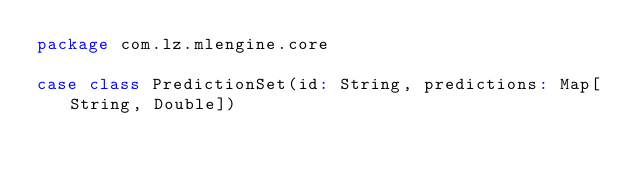<code> <loc_0><loc_0><loc_500><loc_500><_Scala_>package com.lz.mlengine.core

case class PredictionSet(id: String, predictions: Map[String, Double])
</code> 